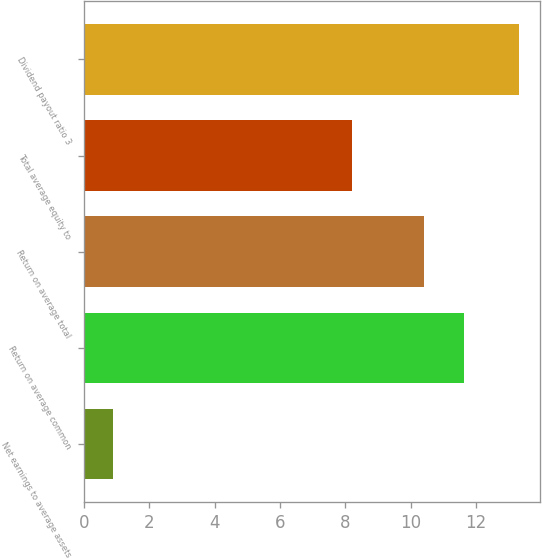Convert chart to OTSL. <chart><loc_0><loc_0><loc_500><loc_500><bar_chart><fcel>Net earnings to average assets<fcel>Return on average common<fcel>Return on average total<fcel>Total average equity to<fcel>Dividend payout ratio 3<nl><fcel>0.9<fcel>11.64<fcel>10.4<fcel>8.2<fcel>13.3<nl></chart> 